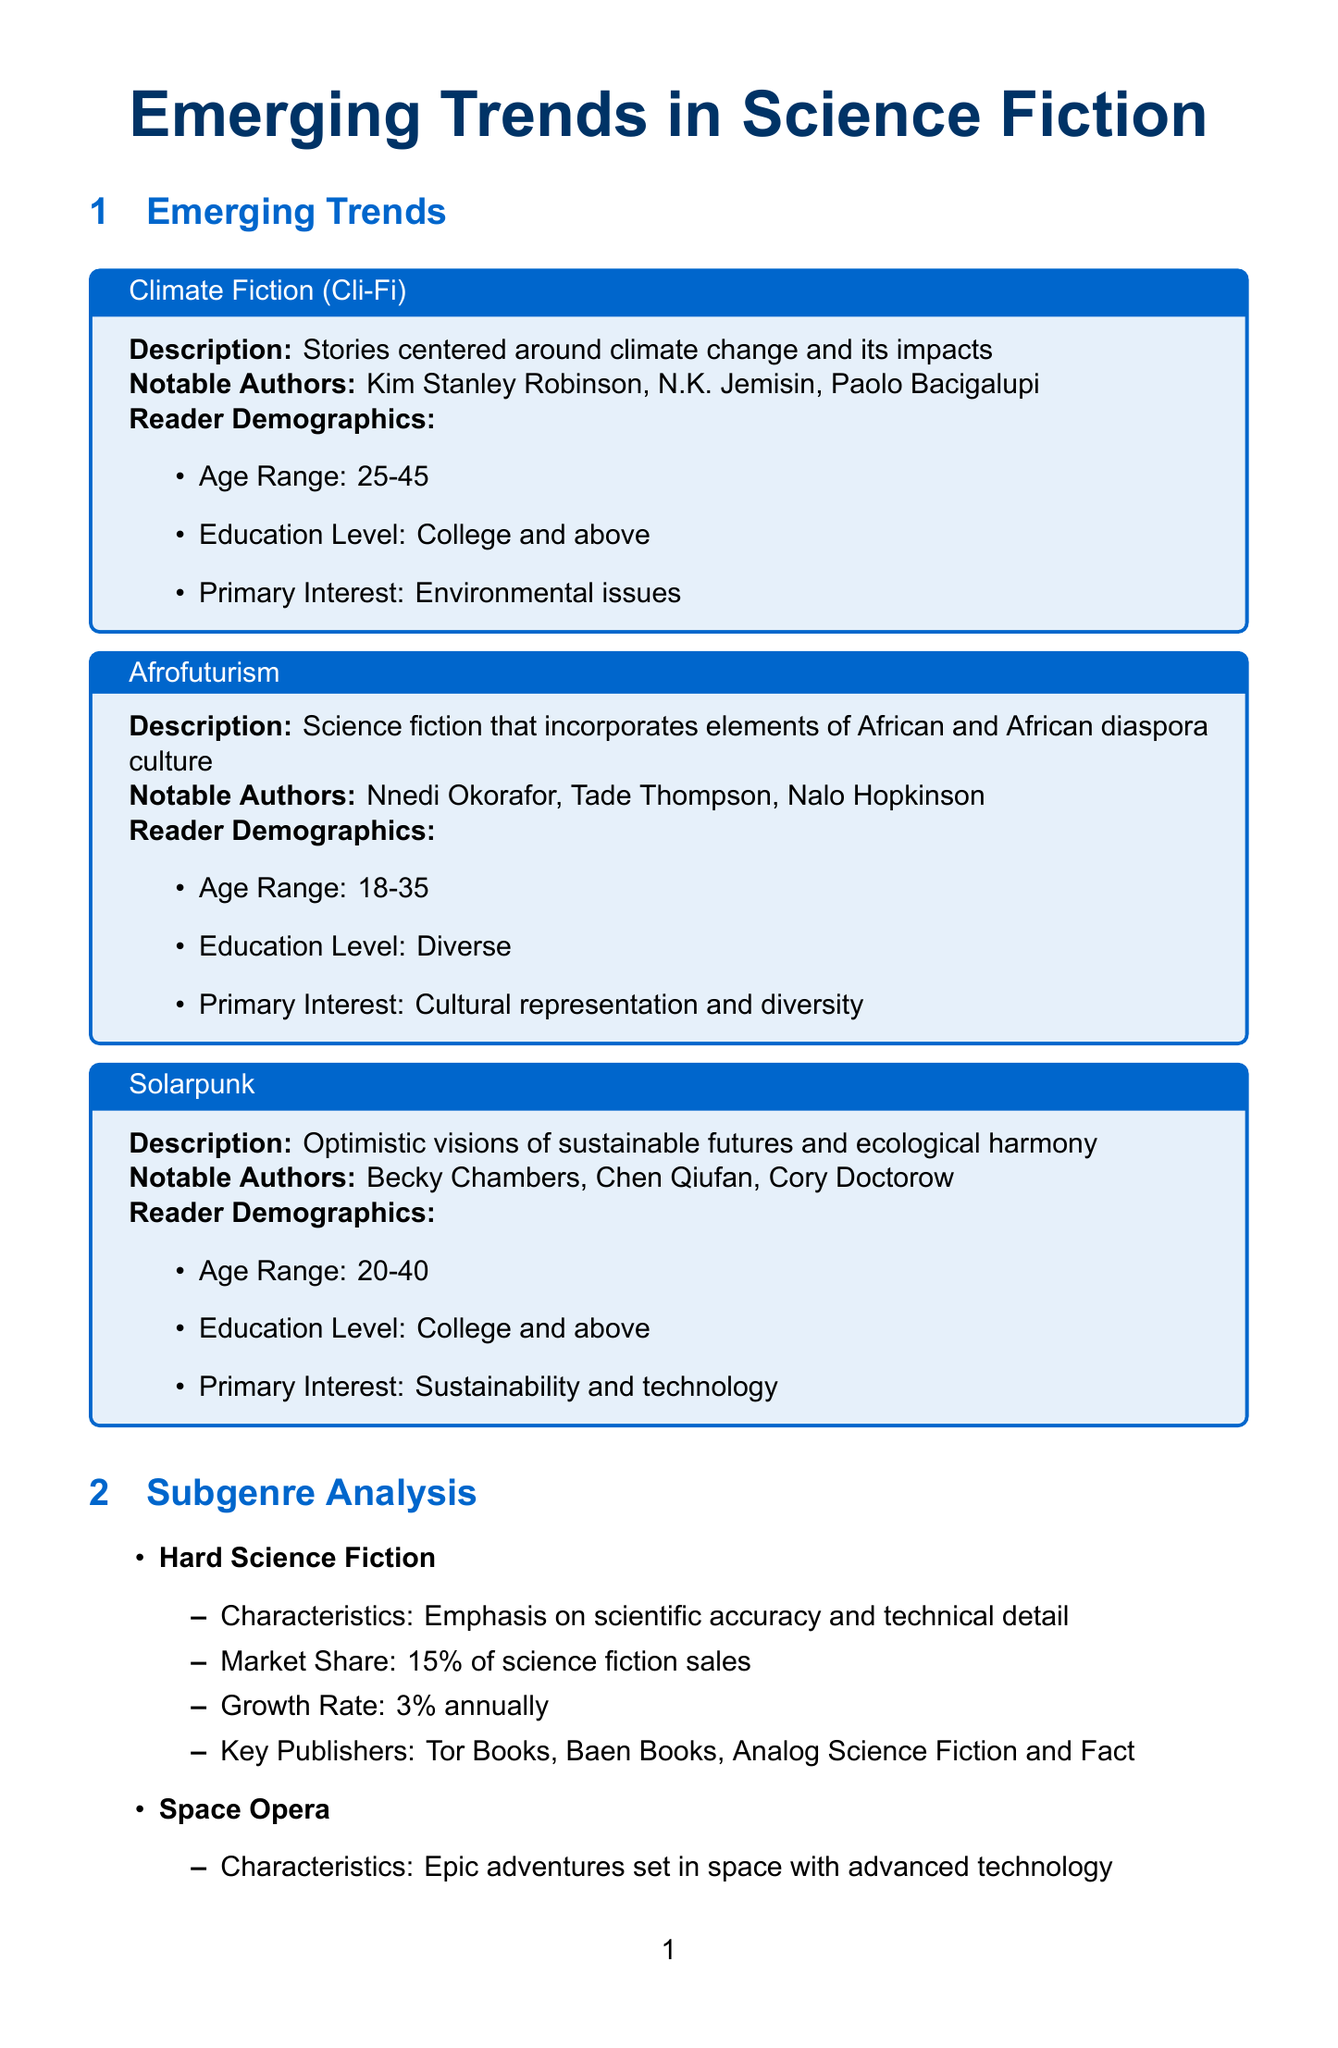What are the notable authors of Climate Fiction? The document lists Kim Stanley Robinson, N.K. Jemisin, and Paolo Bacigalupi as notable authors under the Climate Fiction trend.
Answer: Kim Stanley Robinson, N.K. Jemisin, Paolo Bacigalupi What is the primary interest of Afrofuturism readers? According to the document, the primary interest for Afrofuturism readers is cultural representation and diversity.
Answer: Cultural representation and diversity What is the market share of Space Opera in science fiction sales? The document states that Space Opera has a market share of 25% of science fiction sales.
Answer: 25% Which emerging trend focuses on optimistic visions of sustainable futures? The trend described in the document that focuses on optimistic visions of sustainable futures is Solarpunk.
Answer: Solarpunk What percentage of science fiction readers are male? The document provides information that 55% of science fiction readers are male.
Answer: 55% What is the growth rate of self-publishing in science fiction? The document notes that the growth rate of self-publishing in science fiction is 10% annually.
Answer: 10% Which demographic age range is most interested in Climate Fiction? The document specifies that the age range most interested in Climate Fiction is 25-45 years.
Answer: 25-45 What innovative marketing strategy involves immersive experiences? The document mentions Virtual Reality Book Launches as an innovative marketing strategy that involves immersive experiences.
Answer: Virtual Reality Book Launches What is the total annual market size of the science fiction industry? According to the document, the total annual market size of the science fiction industry is $1.2 billion.
Answer: $1.2 billion 